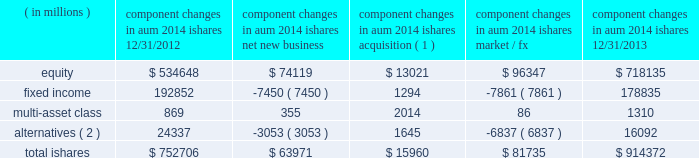The second largest closed-end fund manager and a top- ten manager by aum and 2013 net flows of long-term open-end mutual funds1 .
In 2013 , we were also the leading manager by net flows for long-dated fixed income mutual funds1 .
2022 we have fully integrated our legacy retail and ishares retail distribution teams to create a unified client-facing presence .
As retail clients increasingly use blackrock 2019s capabilities in combination 2014 active , alternative and passive 2014 it is a strategic priority for blackrock to coherently deliver these capabilities through one integrated team .
2022 international retail long-term net inflows of $ 17.5 billion , representing 15% ( 15 % ) organic growth , were positive across major regions and diversified across asset classes .
Equity net inflows of $ 6.4 billion were driven by strong demand for our top-performing european equities franchise as investor risk appetite for the sector improved .
Multi-asset class and fixed income products each generated net inflows of $ 4.8 billion , as investors looked to manage duration and volatility in their portfolios .
In 2013 , we were ranked as the third largest cross border fund provider2 .
In the united kingdom , we ranked among the five largest fund managers2 .
Ishares .
Alternatives ( 2 ) 24337 ( 3053 ) 1645 ( 6837 ) 16092 total ishares $ 752706 $ 63971 $ 15960 $ 81735 $ 914372 ( 1 ) amounts represent $ 16.0 billion of aum acquired in the credit suisse etf acquisition in july 2013 .
( 2 ) amounts include commodity ishares .
Ishares is the leading etf provider in the world , with $ 914.4 billion of aum at december 31 , 2013 , and was the top asset gatherer globally in 20133 with $ 64.0 billion of net inflows for an organic growth rate of 8% ( 8 % ) .
Equity net inflows of $ 74.1 billion were driven by flows into funds with broad developed market exposures , partially offset by outflows from emerging markets products .
Ishares fixed income experienced net outflows of $ 7.5 billion , as the continued low interest rate environment led many liquidity-oriented investors to sell long-duration assets , which made up the majority of the ishares fixed income suite .
In 2013 , we launched several funds to meet demand from clients seeking protection in a rising interest rate environment by offering an expanded product set that includes four new u.s .
Funds , including short-duration versions of our flagship high yield and investment grade credit products , and short maturity and liquidity income funds .
Ishares alternatives had $ 3.1 billion of net outflows predominantly out of commodities .
Ishares represented 23% ( 23 % ) of long-term aum at december 31 , 2013 and 35% ( 35 % ) of long-term base fees for ishares offers the most diverse product set in the industry with 703 etfs at year-end 2013 , and serves the broadest client base , covering more than 25 countries on five continents .
During 2013 , ishares continued its dual commitment to innovation and responsible product structuring by introducing 42 new etfs , acquiring credit suisse 2019s 58 etfs in europe and entering into a critical new strategic alliance with fidelity investments to deliver fidelity 2019s more than 10 million clients increased access to ishares products , tools and support .
Our alliance with fidelity investments and a successful full first year for the core series have deeply expanded our presence and offerings among buy-and-hold investors .
Our broad product range offers investors a precise , transparent and low-cost way to tap market returns and gain access to a full range of asset classes and global markets that have been difficult or expensive for many investors to access until now , as well as the liquidity required to make adjustments to their exposures quickly and cost-efficiently .
2022 u.s .
Ishares aum ended at $ 655.6 billion with $ 41.4 billion of net inflows driven by strong demand for developed markets equities and short-duration fixed income .
During the fourth quarter of 2012 , we debuted the core series in the united states , designed to provide the essential building blocks for buy-and-hold investors to use in constructing the core of their portfolio .
The core series demonstrated solid results in its first full year , raising $ 20.0 billion in net inflows , primarily in u.s .
Equities .
In the united states , ishares maintained its position as the largest etf provider , with 39% ( 39 % ) share of aum3 .
2022 international ishares aum ended at $ 258.8 billion with robust net new business of $ 22.6 billion led by demand for european and japanese equities , as well as a diverse range of fixed income products .
At year-end 2013 , ishares was the largest european etf provider with 48% ( 48 % ) of aum3 .
1 simfund 2 lipper feri 3 blackrock ; bloomberg .
What percent did the net inflows increase ishares aum? 
Computations: (41.4 / (655.6 - 41.4))
Answer: 0.0674. 